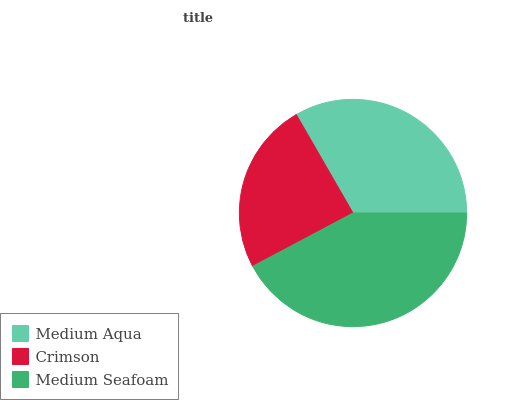Is Crimson the minimum?
Answer yes or no. Yes. Is Medium Seafoam the maximum?
Answer yes or no. Yes. Is Medium Seafoam the minimum?
Answer yes or no. No. Is Crimson the maximum?
Answer yes or no. No. Is Medium Seafoam greater than Crimson?
Answer yes or no. Yes. Is Crimson less than Medium Seafoam?
Answer yes or no. Yes. Is Crimson greater than Medium Seafoam?
Answer yes or no. No. Is Medium Seafoam less than Crimson?
Answer yes or no. No. Is Medium Aqua the high median?
Answer yes or no. Yes. Is Medium Aqua the low median?
Answer yes or no. Yes. Is Crimson the high median?
Answer yes or no. No. Is Medium Seafoam the low median?
Answer yes or no. No. 